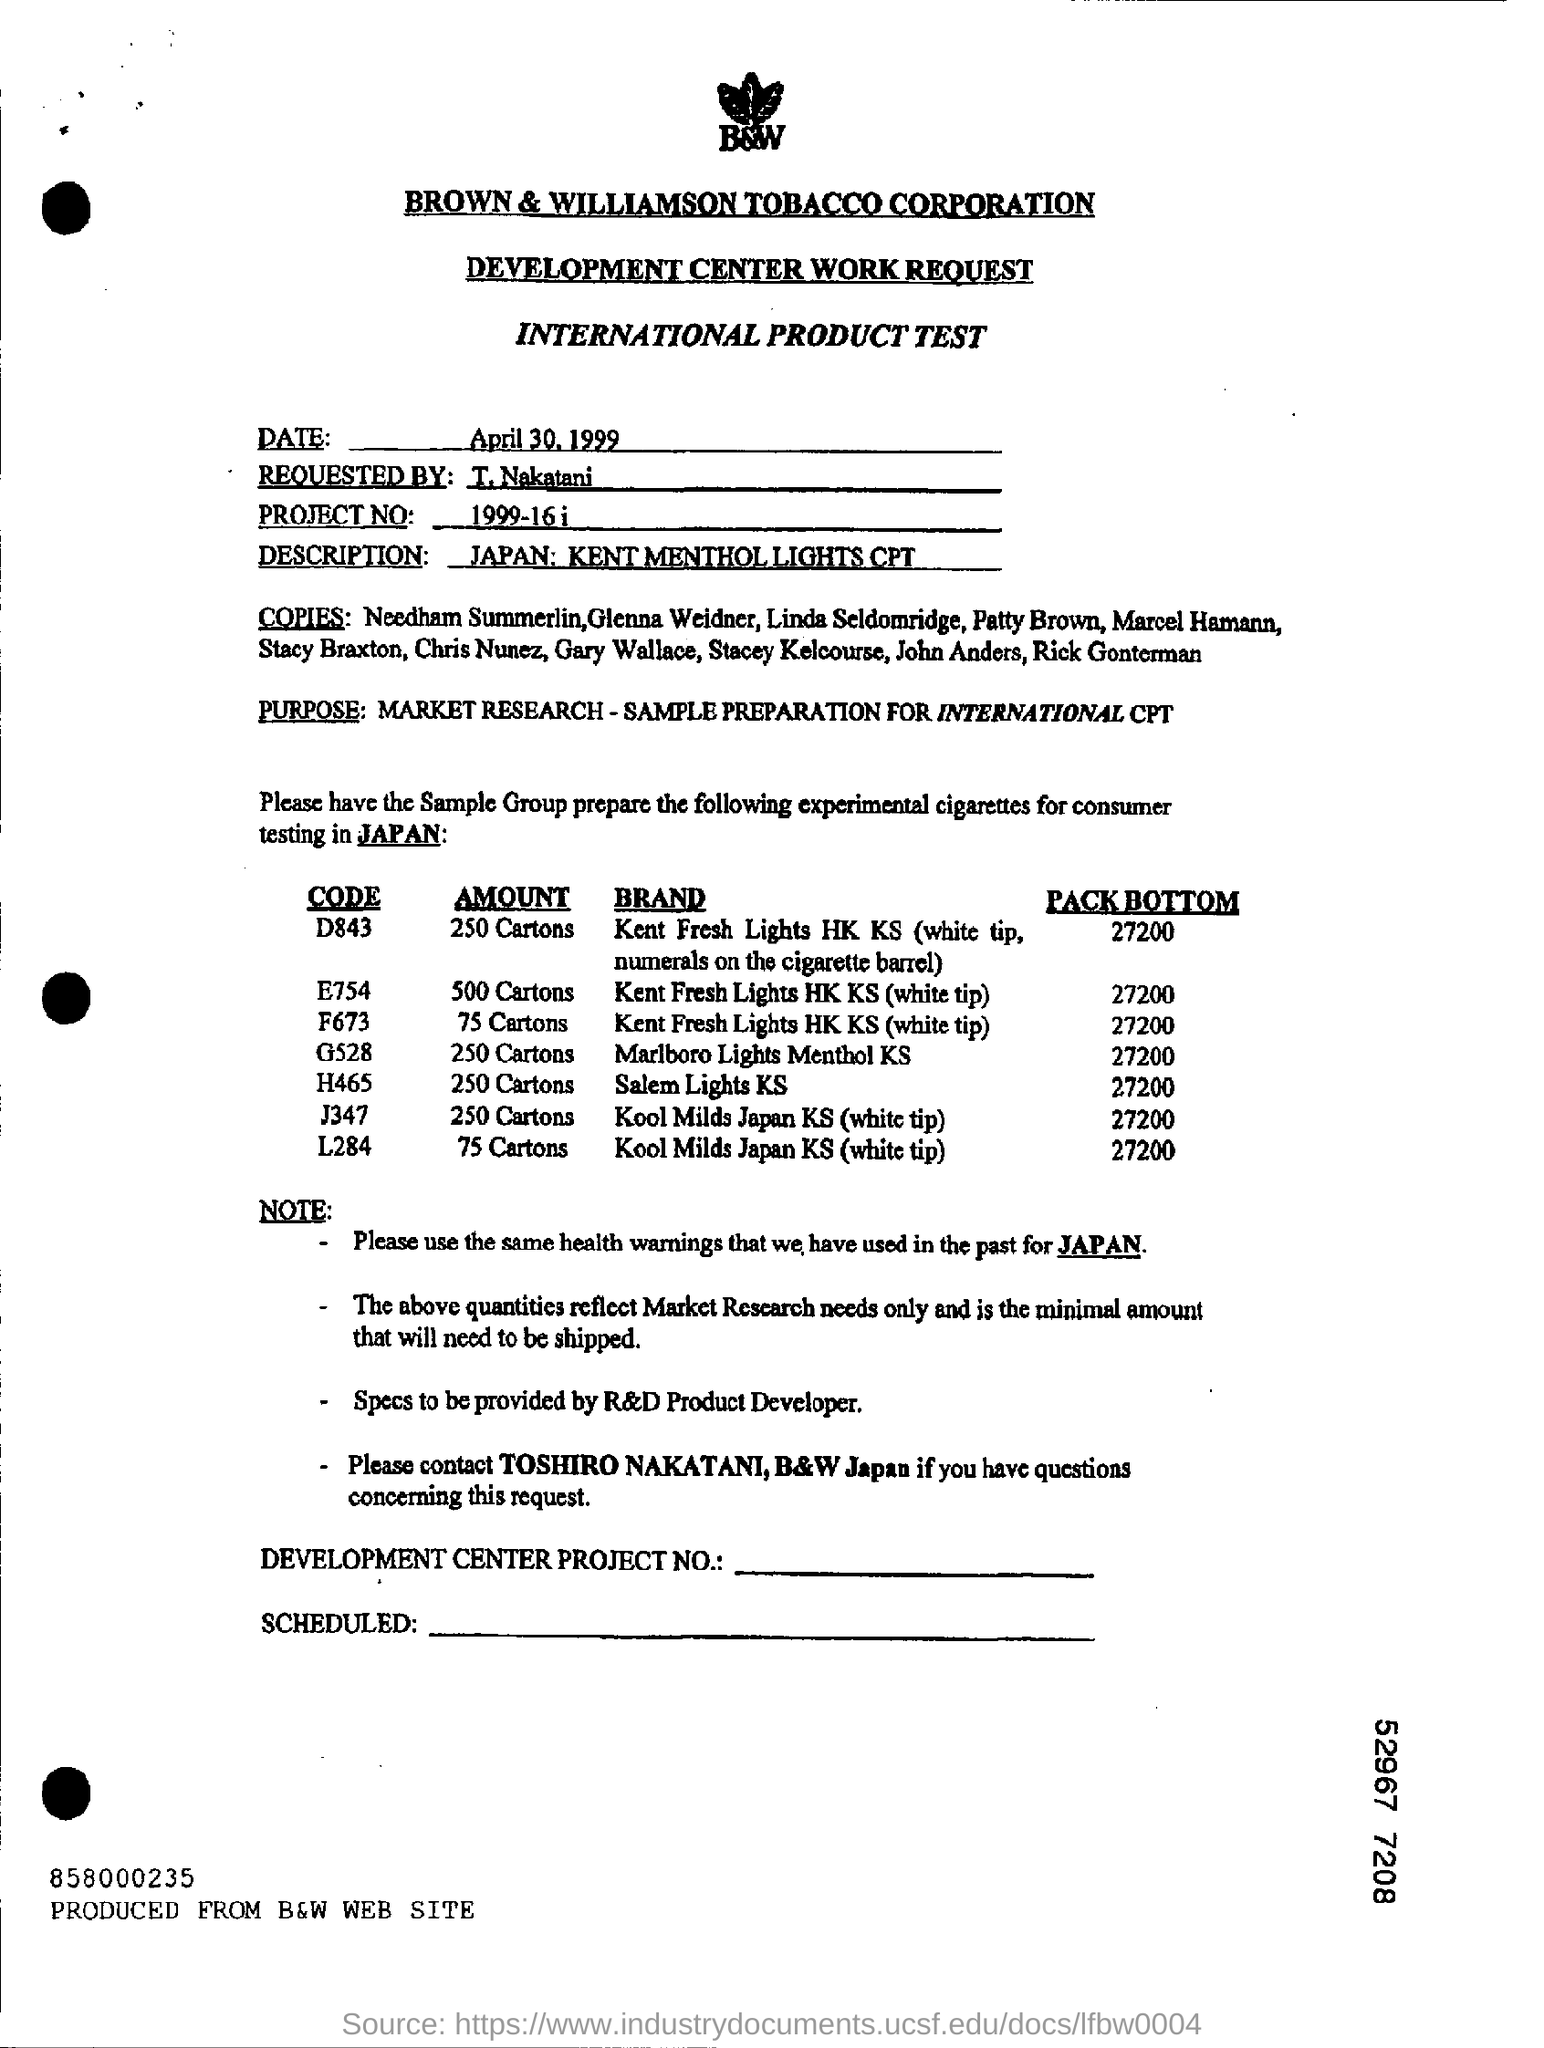What is the project number ?
Provide a succinct answer. 1999-16 i. What is the code for salem lights KS ?
Your answer should be compact. H465. Who requested the product test?
Ensure brevity in your answer.  T.Nakatani. What is the code for Marlboro Lights Menthol KS ?
Provide a succinct answer. G528. 